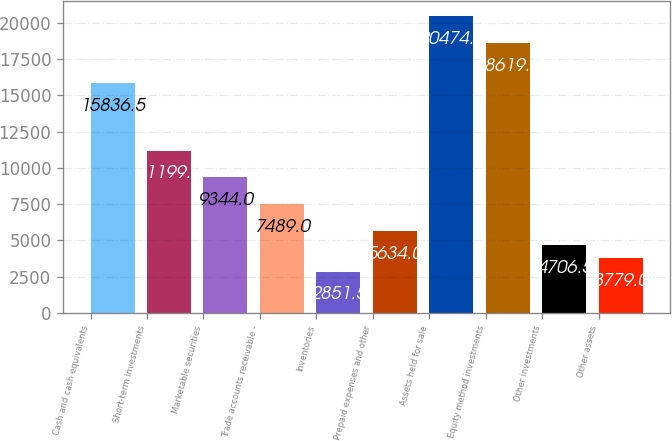Convert chart. <chart><loc_0><loc_0><loc_500><loc_500><bar_chart><fcel>Cash and cash equivalents<fcel>Short-term investments<fcel>Marketable securities<fcel>Trade accounts receivable -<fcel>Inventories<fcel>Prepaid expenses and other<fcel>Assets held for sale<fcel>Equity method investments<fcel>Other investments<fcel>Other assets<nl><fcel>15836.5<fcel>11199<fcel>9344<fcel>7489<fcel>2851.5<fcel>5634<fcel>20474<fcel>18619<fcel>4706.5<fcel>3779<nl></chart> 